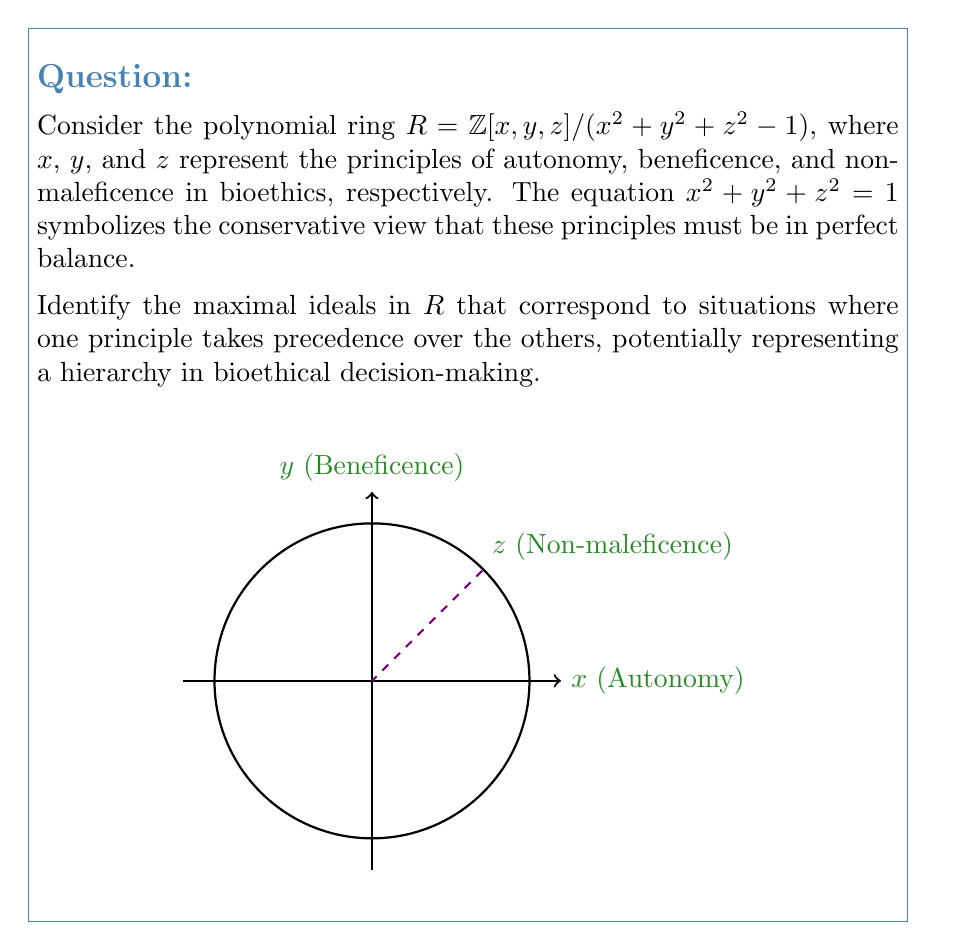Help me with this question. To solve this problem, we need to follow these steps:

1) First, recall that in a polynomial ring, maximal ideals correspond to points on the variety defined by the polynomial.

2) In this case, the variety is the unit sphere $x^2 + y^2 + z^2 = 1$ in $\mathbb{R}^3$.

3) The maximal ideals in $R$ will correspond to the points on this sphere where one coordinate is $\pm 1$ and the others are 0. These points represent situations where one principle is fully prioritized over the others.

4) There are six such points on the unit sphere:
   $(\pm 1, 0, 0)$, $(0, \pm 1, 0)$, and $(0, 0, \pm 1)$

5) The maximal ideals corresponding to these points are:
   $M_1 = (x - 1, y, z)$
   $M_2 = (x + 1, y, z)$
   $M_3 = (x, y - 1, z)$
   $M_4 = (x, y + 1, z)$
   $M_5 = (x, y, z - 1)$
   $M_6 = (x, y, z + 1)$

6) In the context of bioethics:
   $M_1$ and $M_2$ represent situations where autonomy is prioritized
   $M_3$ and $M_4$ represent situations where beneficence is prioritized
   $M_5$ and $M_6$ represent situations where non-maleficence is prioritized

7) The positive values ($M_1$, $M_3$, $M_5$) could represent the principle being upheld, while the negative values ($M_2$, $M_4$, $M_6$) could represent the principle being violated or neglected.
Answer: The maximal ideals are $M_1 = (x - 1, y, z)$, $M_2 = (x + 1, y, z)$, $M_3 = (x, y - 1, z)$, $M_4 = (x, y + 1, z)$, $M_5 = (x, y, z - 1)$, and $M_6 = (x, y, z + 1)$. 